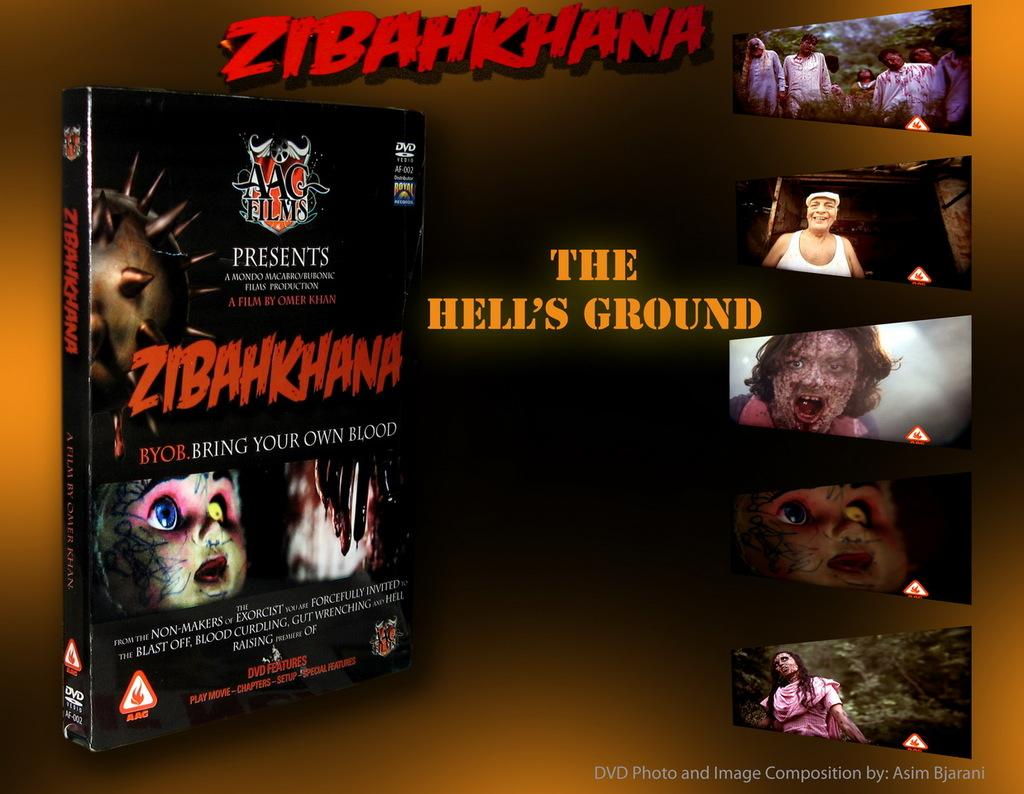What is the main subject of the image? There is a collage in the image. What can be seen within the collage? There are persons, text, and a DVD box in the collage. What is written on the DVD box? There is text on the DVD box. How would you describe the overall appearance of the image? The background of the image is dark. How many yards are visible in the image? There are no yards present in the image; it features a collage with various elements. What is the temperature of the fifth person in the collage? There is no information about the temperature or the number of persons in the collage, as only the presence of persons is mentioned. 